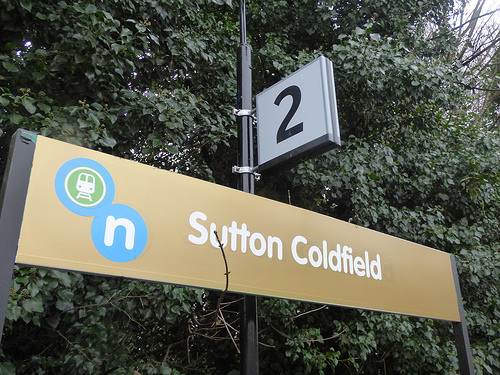<image>
Can you confirm if the board is behind the sign? No. The board is not behind the sign. From this viewpoint, the board appears to be positioned elsewhere in the scene. 